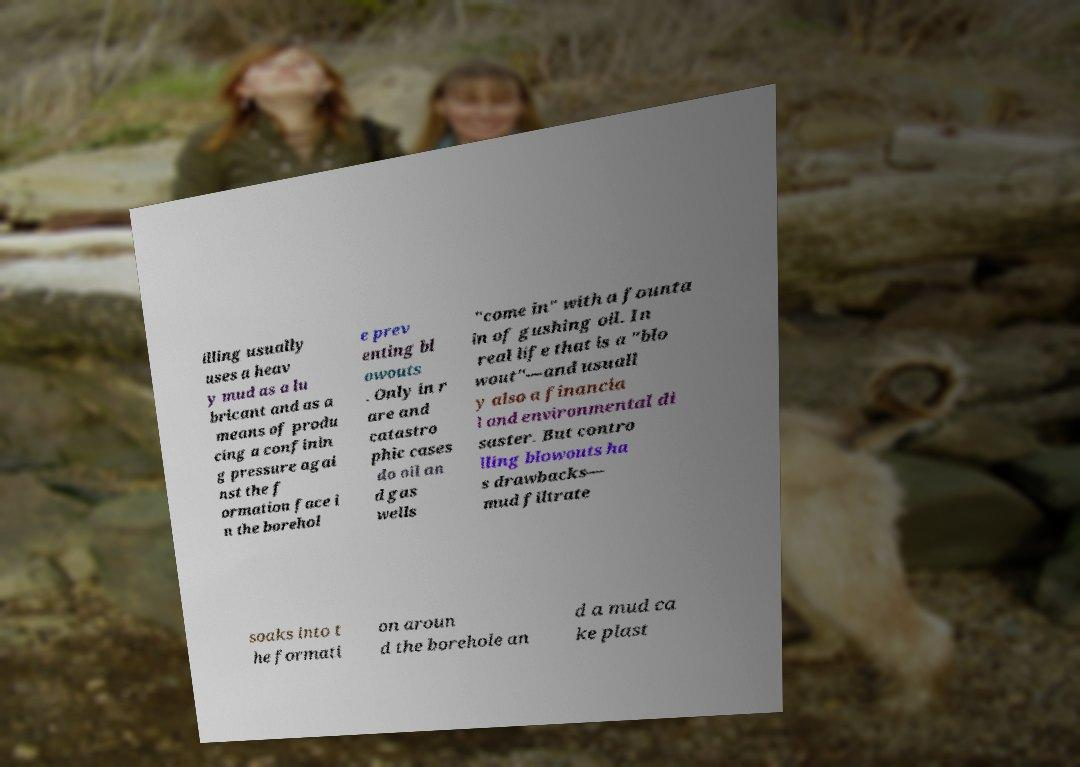Could you extract and type out the text from this image? illing usually uses a heav y mud as a lu bricant and as a means of produ cing a confinin g pressure agai nst the f ormation face i n the borehol e prev enting bl owouts . Only in r are and catastro phic cases do oil an d gas wells "come in" with a founta in of gushing oil. In real life that is a "blo wout"—and usuall y also a financia l and environmental di saster. But contro lling blowouts ha s drawbacks— mud filtrate soaks into t he formati on aroun d the borehole an d a mud ca ke plast 